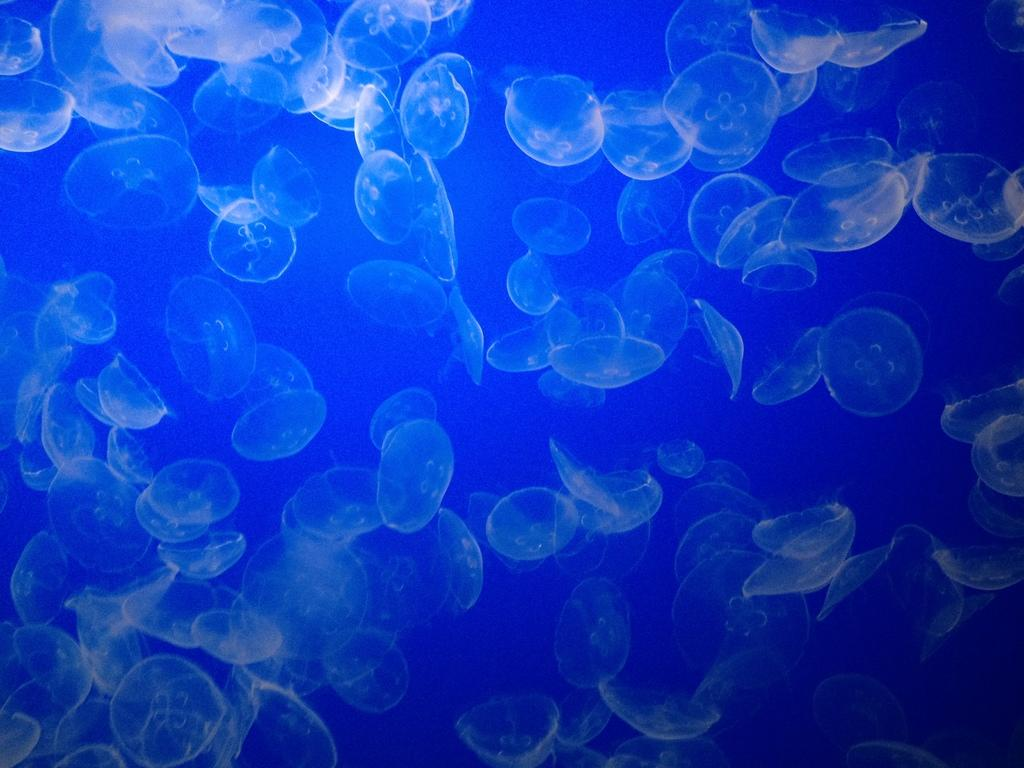What type of animals can be seen in the image? There are fishes in the image. Where are the fishes located? The fishes are in water. What type of gold object can be seen in the image? There is no gold object present in the image; it features fishes in water. What type of beast or creature is interacting with the fishes in the image? There is no beast or creature interacting with the fishes in the image; only the fishes and water are present. 